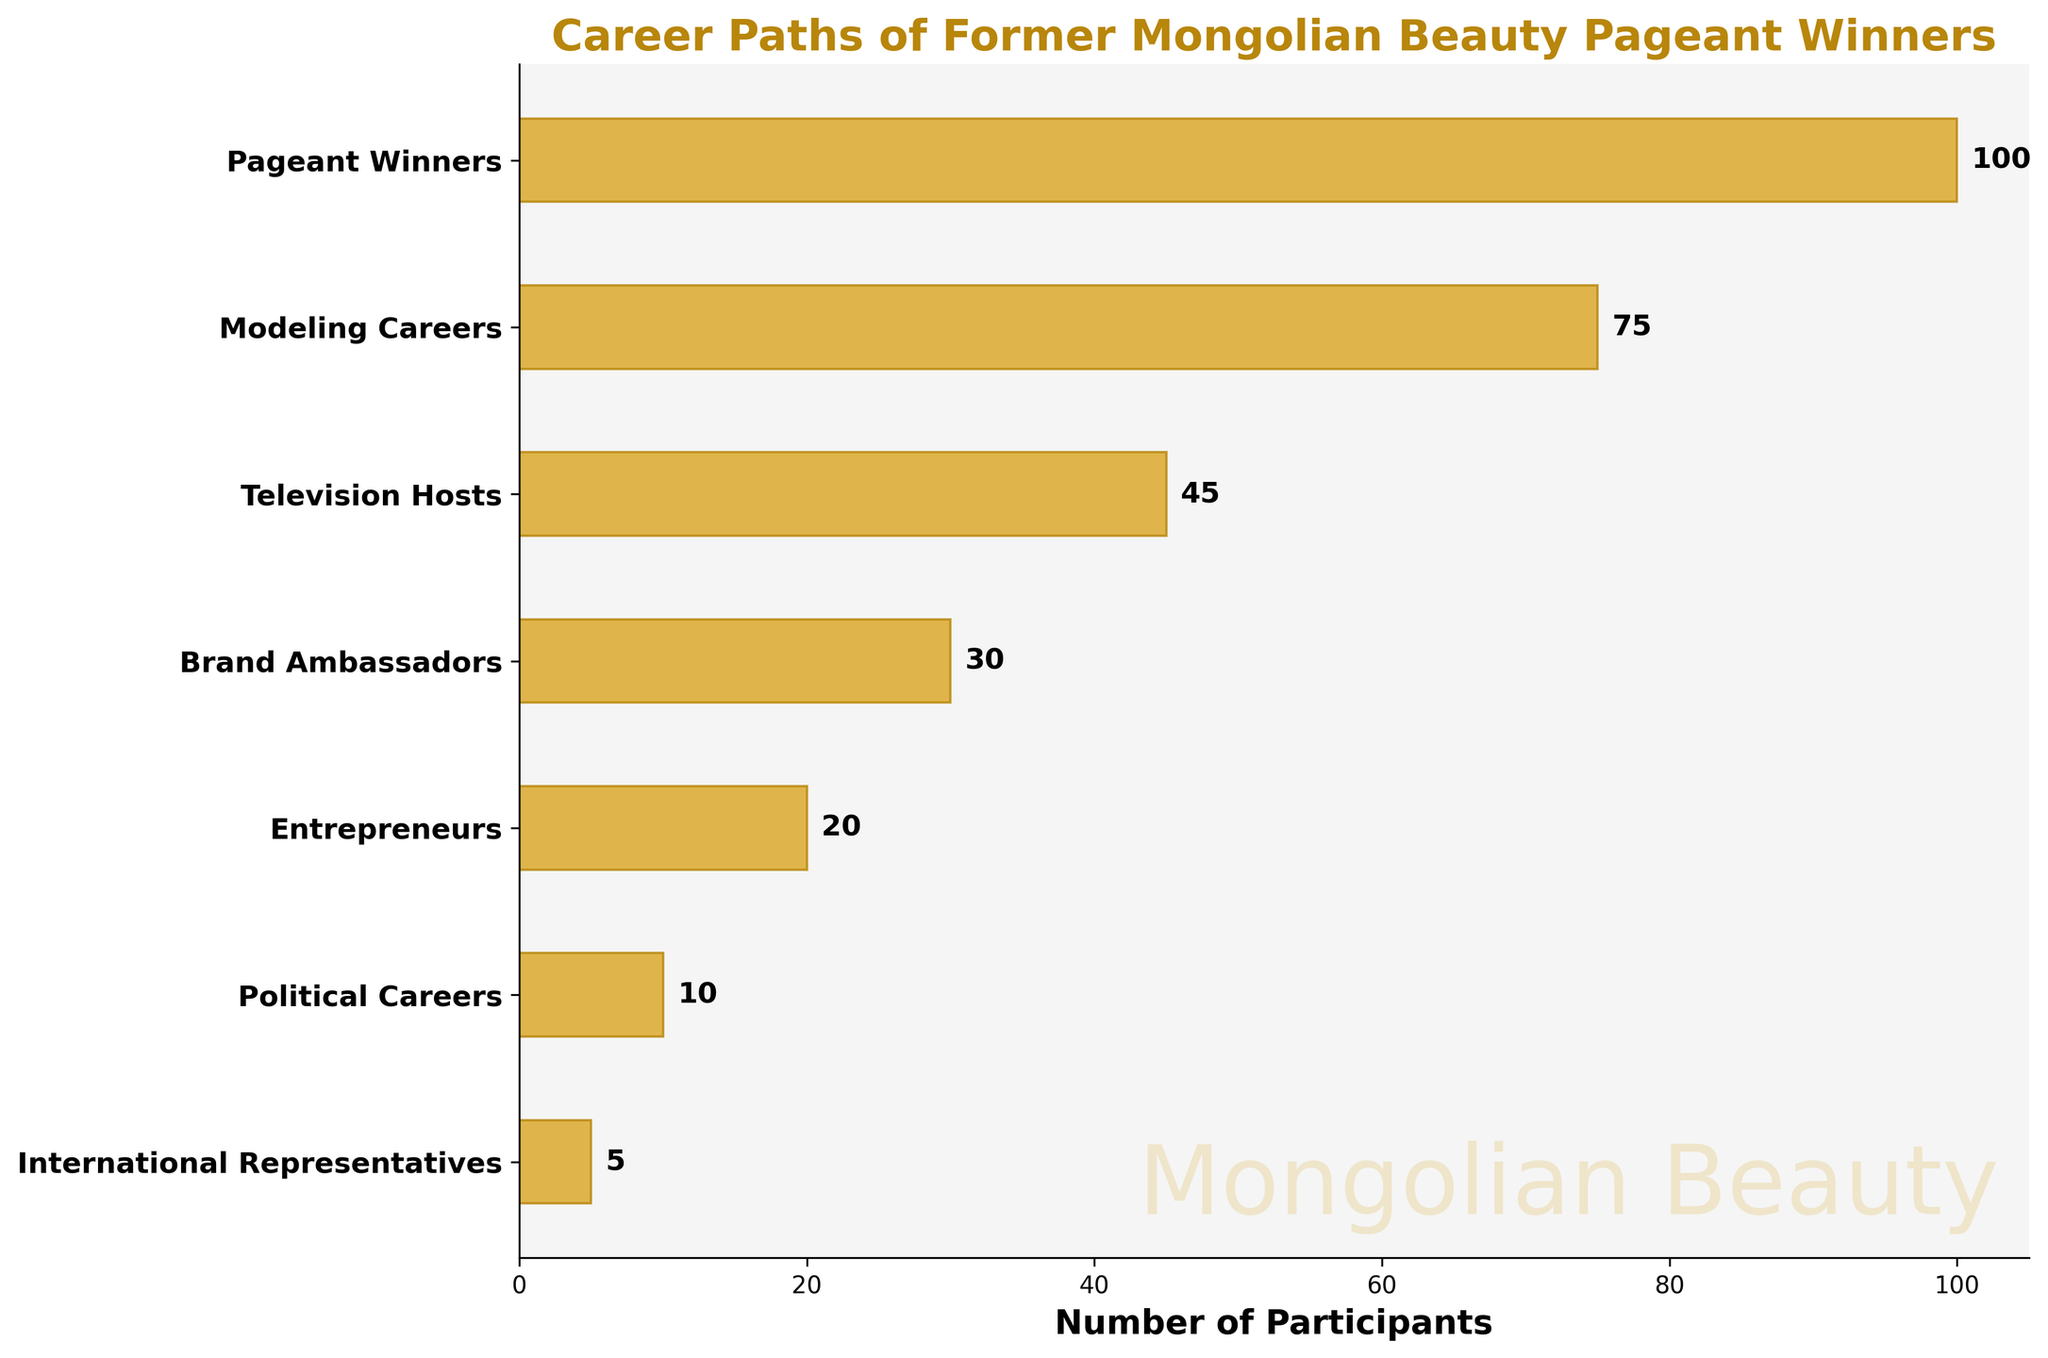what is the title of the figure? The title of the figure is formatted in bold and colored dark goldenrod above the horizontal bars. It provides an overview of the content.
Answer: Career Paths of Former Mongolian Beauty Pageant Winners how many stages are displayed in the funnel chart? Count the number of horizontal bars, each representing a stage in the career path.
Answer: 7 what is the maximum number of participants at any stage, and which stage does it correspond to? Look at the values beside each horizontal bar and identify the largest one. It corresponds to the initial stage in the funnel.
Answer: 100, Pageant Winners which career path has the fewest participants, and how many? Identify the horizontal bar with the smallest value and note the corresponding stage and its value.
Answer: International Representatives, 5 what can you infer about the transition from being a Pageant Winner to becoming an International Representative? Notice the significant decrease in the number of participants from the first stage to the last, indicating that very few pageant winners reach the International Representative stage. From 100 Pageant Winners, only 5 become International Representatives.
Answer: significant decrease 